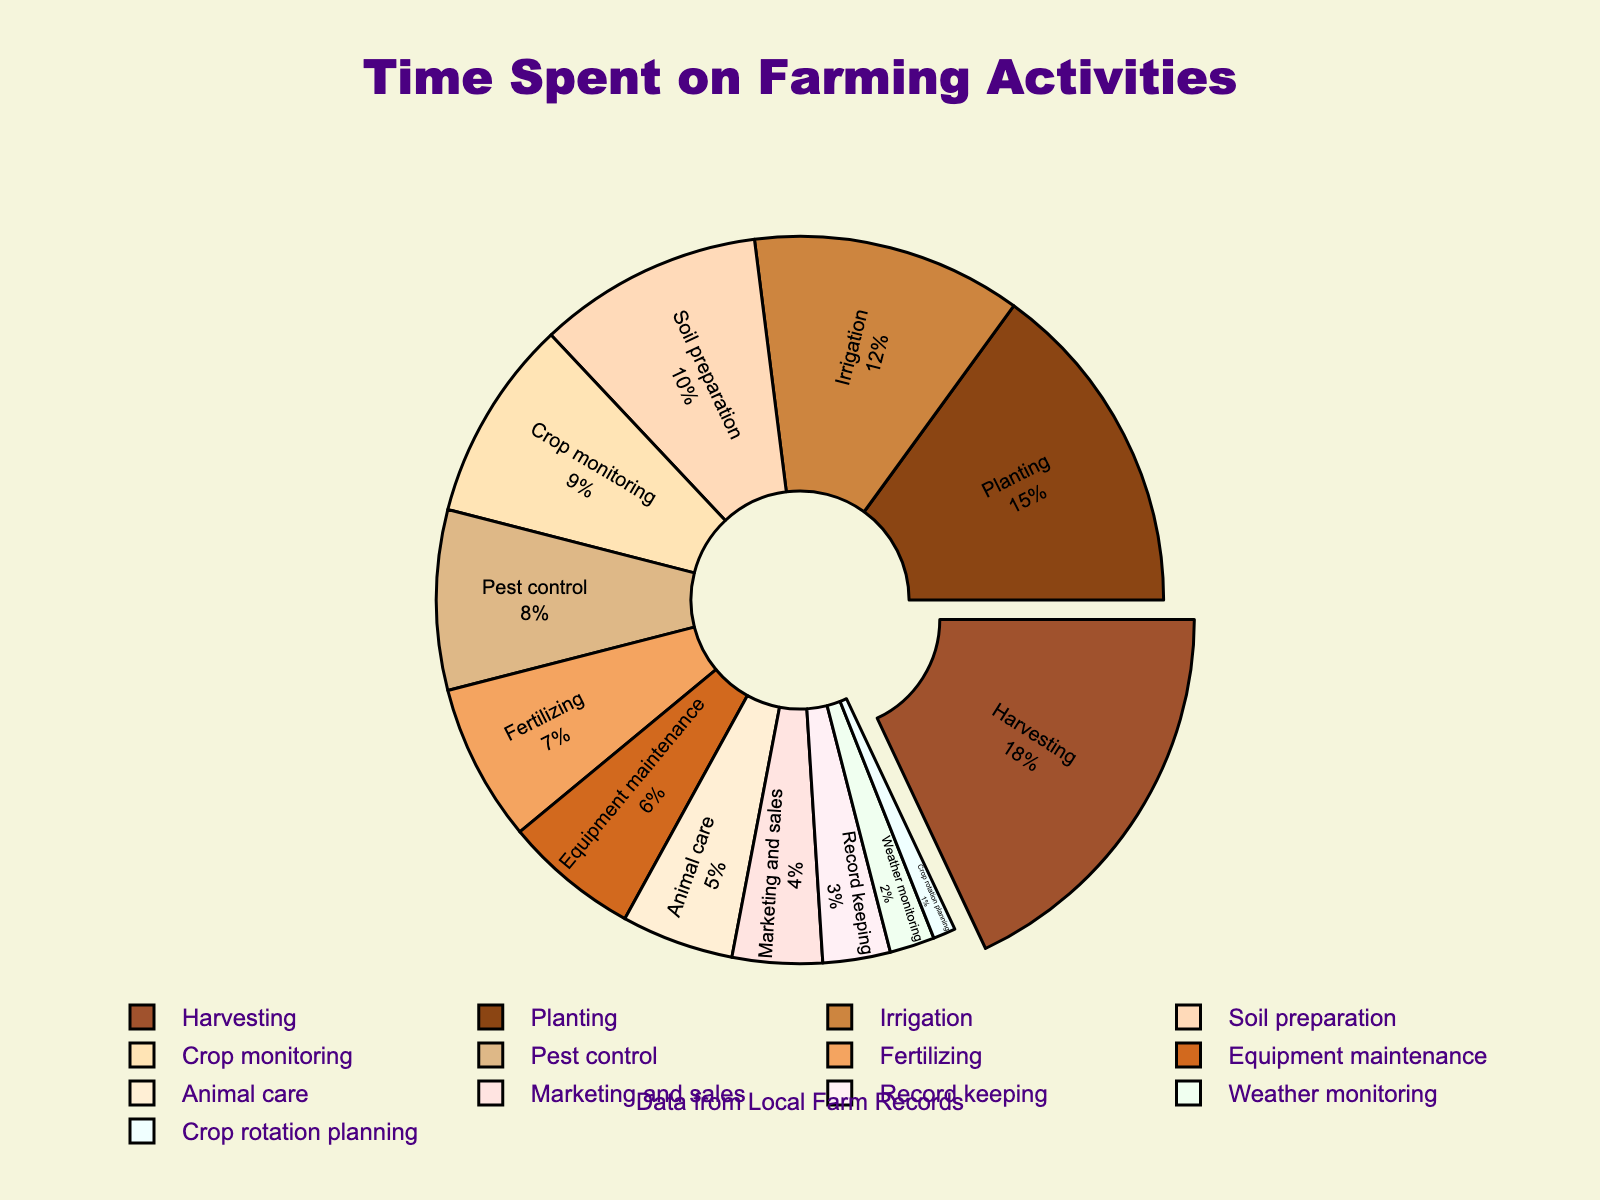What percentage of time is spent on Harvesting? The chart shows the percentage of time spent on each farming activity. Harvesting is one of the labeled segments.
Answer: 18% How much more time is spent on Planting compared to Pest control? We compare the percentages for Planting (15%) and Pest control (8%). The difference is 15% - 8% = 7%.
Answer: 7% Which activity has the lowest percentage of time spent? Find the segment with the smallest percentage in the chart. Crop rotation planning has the lowest percentage.
Answer: Crop rotation planning How many activities have a percentage of time spent that is less than 10%? Count the segments with percentages less than 10%. These are Pest control, Fertilizing, Equipment maintenance, Crop monitoring, Animal care, Marketing and sales, Record keeping, Weather monitoring, Crop rotation planning.
Answer: 9 What is the combined percentage of time spent on Irrigation and Soil preparation? Add the percentages of these two activities: Irrigation (12%) and Soil preparation (10%). 12% + 10% = 22%.
Answer: 22% Is more time spent on Pest control or Marketing and sales? Compare the percentages of time spent on these two activities. Pest control is 8%, and Marketing and sales is 4%.
Answer: Pest control Which activity has a larger percentage of time allocated: Animal care or Record keeping? Compare the percentages: Animal care (5%) and Record keeping (3%).
Answer: Animal care What are the top three activities in terms of time spent? Look at the largest segments. The top three are Harvesting (18%), Planting (15%), and Irrigation (12%).
Answer: Harvesting, Planting, Irrigation How much time is spent on activities that are not directly related to crop management (e.g., excluding Planting, Harvesting, Irrigation, etc.)? Calculate the sum of percentages of activities unrelated to crop management: Equipment maintenance (6%), Animal care (5%), Marketing and sales (4%), Record keeping (3%), Weather monitoring (2%), Crop rotation planning (1%). Sum is 6% + 5% + 4% + 3% + 2% + 1% = 21%.
Answer: 21% 